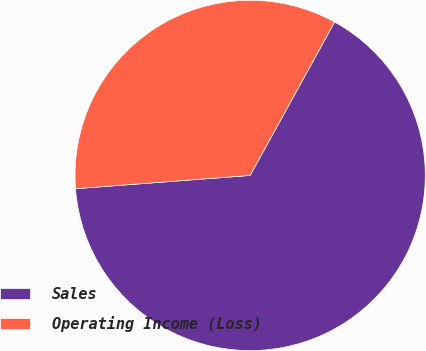<chart> <loc_0><loc_0><loc_500><loc_500><pie_chart><fcel>Sales<fcel>Operating Income (Loss)<nl><fcel>65.78%<fcel>34.22%<nl></chart> 